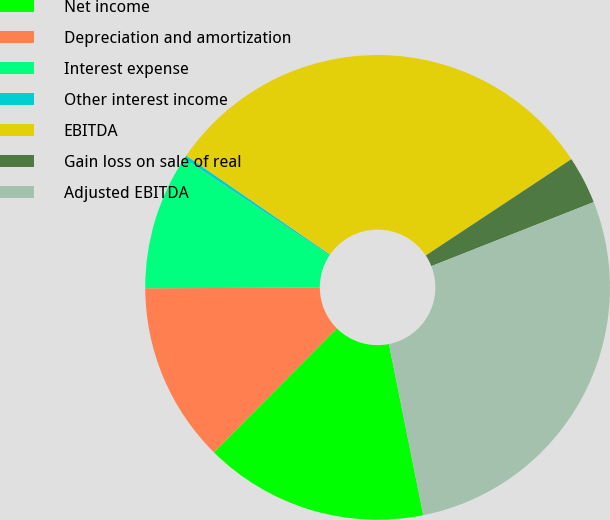<chart> <loc_0><loc_0><loc_500><loc_500><pie_chart><fcel>Net income<fcel>Depreciation and amortization<fcel>Interest expense<fcel>Other interest income<fcel>EBITDA<fcel>Gain loss on sale of real<fcel>Adjusted EBITDA<nl><fcel>15.59%<fcel>12.5%<fcel>9.42%<fcel>0.24%<fcel>31.1%<fcel>3.32%<fcel>27.83%<nl></chart> 